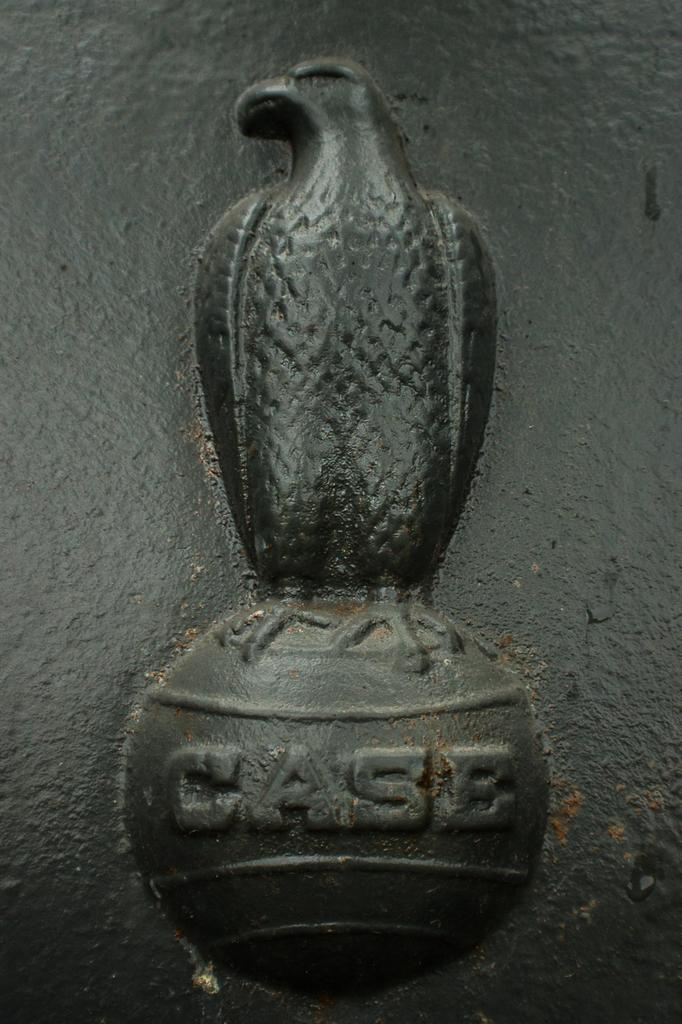What is the main subject of the image? The main subject of the image is a sculpture of a bird. What color is the sculpture? The sculpture is black in color. Is there any text associated with the sculpture in the image? Yes, there is a word written under the sculpture. What type of property can be seen near the coast in the image? There is no property or coast visible in the image; it only features a black sculpture of a bird with a word written underneath it. 